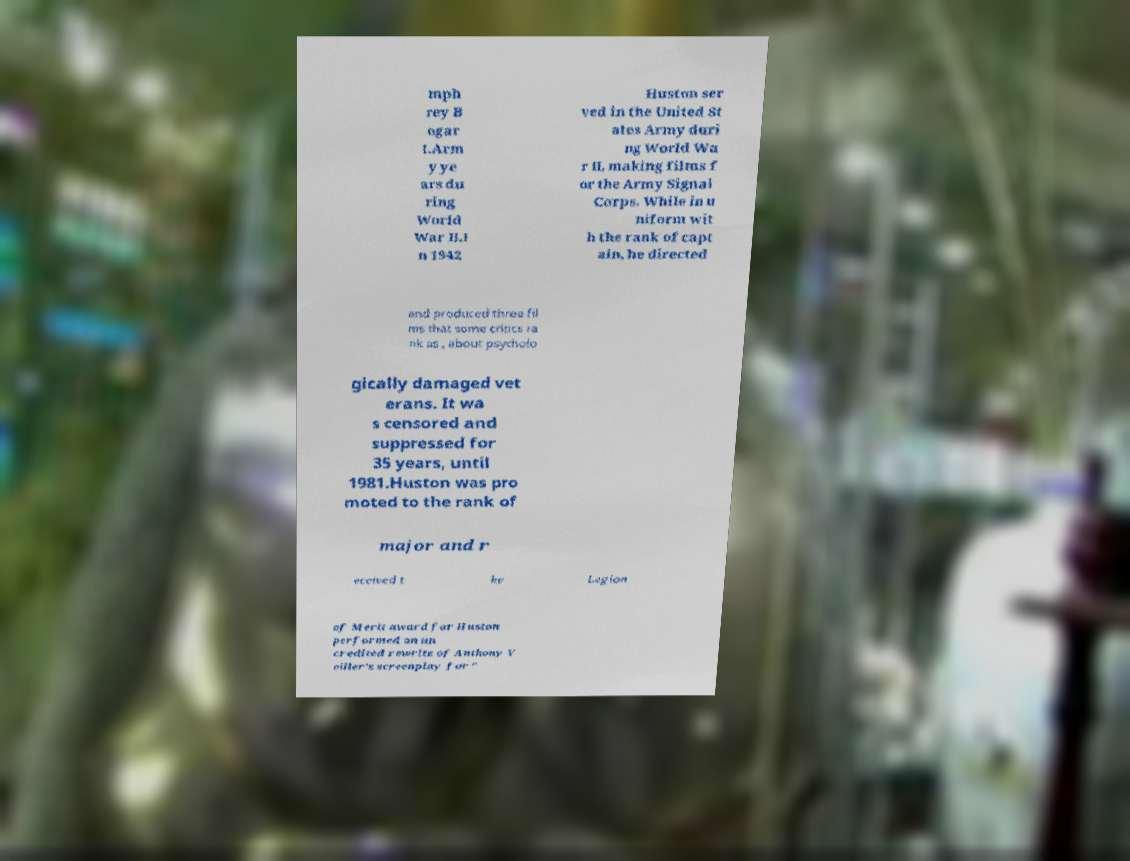Please read and relay the text visible in this image. What does it say? mph rey B ogar t.Arm y ye ars du ring World War II.I n 1942 Huston ser ved in the United St ates Army duri ng World Wa r II, making films f or the Army Signal Corps. While in u niform wit h the rank of capt ain, he directed and produced three fil ms that some critics ra nk as , about psycholo gically damaged vet erans. It wa s censored and suppressed for 35 years, until 1981.Huston was pro moted to the rank of major and r eceived t he Legion of Merit award for Huston performed an un credited rewrite of Anthony V eiller's screenplay for " 